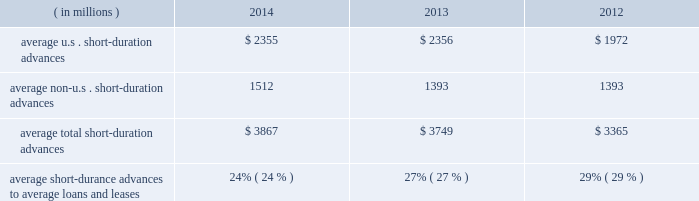Management 2019s discussion and analysis of financial condition and results of operations ( continued ) detail with respect to our investment portfolio as of december 31 , 2014 and 2013 is provided in note 3 to the consolidated financial statements included under item 8 of this form 10-k .
Loans and leases averaged $ 15.91 billion for the year ended 2014 , up from $ 13.78 billion in 2013 .
The increase was mainly related to mutual fund lending and our continued investment in senior secured bank loans .
Mutual fund lending and senior secured bank loans averaged approximately $ 9.12 billion and $ 1.40 billion , respectively , for the year ended december 31 , 2014 compared to $ 8.16 billion and $ 170 million for the year ended december 31 , 2013 , respectively .
Average loans and leases also include short- duration advances .
Table 13 : u.s .
And non-u.s .
Short-duration advances years ended december 31 .
Average u.s .
Short-duration advances $ 2355 $ 2356 $ 1972 average non-u.s .
Short-duration advances 1512 1393 1393 average total short-duration advances $ 3867 $ 3749 $ 3365 average short-durance advances to average loans and leases 24% ( 24 % ) 27% ( 27 % ) 29% ( 29 % ) the decline in proportion of the average daily short-duration advances to average loans and leases is primarily due to growth in the other segments of the loan and lease portfolio .
Short-duration advances provide liquidity to clients in support of their investment activities .
Although average short-duration advances for the year ended december 31 , 2014 increased compared to the year ended december 31 , 2013 , such average advances remained low relative to historical levels , mainly the result of clients continuing to hold higher levels of liquidity .
Average other interest-earning assets increased to $ 15.94 billion for the year ended december 31 , 2014 from $ 11.16 billion for the year ended december 31 , 2013 .
The increased levels were primarily the result of higher levels of cash collateral provided in connection with our enhanced custody business .
Aggregate average interest-bearing deposits increased to $ 130.30 billion for the year ended december 31 , 2014 from $ 109.25 billion for year ended 2013 .
The higher levels were primarily the result of increases in both u.s .
And non-u.s .
Transaction accounts and time deposits .
Future transaction account levels will be influenced by the underlying asset servicing business , as well as market conditions , including the general levels of u.s .
And non-u.s .
Interest rates .
Average other short-term borrowings increased to $ 4.18 billion for the year ended december 31 , 2014 from $ 3.79 billion for the year ended 2013 .
The increase was the result of a higher level of client demand for our commercial paper .
The decline in rates paid from 1.6% ( 1.6 % ) in 2013 to 0.1% ( 0.1 % ) in 2014 resulted from a reclassification of certain derivative contracts that hedge our interest-rate risk on certain assets and liabilities , which reduced interest revenue and interest expense .
Average long-term debt increased to $ 9.31 billion for the year ended december 31 , 2014 from $ 8.42 billion for the year ended december 31 , 2013 .
The increase primarily reflected the issuance of $ 1.5 billion of senior and subordinated debt in may 2013 , $ 1.0 billion of senior debt issued in november 2013 , and $ 1.0 billion of senior debt issued in december 2014 .
This is partially offset by the maturities of $ 500 million of senior debt in may 2014 and $ 250 million of senior debt in march 2014 .
Average other interest-bearing liabilities increased to $ 7.35 billion for the year ended december 31 , 2014 from $ 6.46 billion for the year ended december 31 , 2013 , primarily the result of higher levels of cash collateral received from clients in connection with our enhanced custody business .
Several factors could affect future levels of our net interest revenue and margin , including the mix of client liabilities ; actions of various central banks ; changes in u.s .
And non-u.s .
Interest rates ; changes in the various yield curves around the world ; revised or proposed regulatory capital or liquidity standards , or interpretations of those standards ; the amount of discount accretion generated by the former conduit securities that remain in our investment securities portfolio ; and the yields earned on securities purchased compared to the yields earned on securities sold or matured .
Based on market conditions and other factors , we continue to reinvest the majority of the proceeds from pay-downs and maturities of investment securities in highly-rated securities , such as u.s .
Treasury and agency securities , municipal securities , federal agency mortgage-backed securities and u.s .
And non-u.s .
Mortgage- and asset-backed securities .
The pace at which we continue to reinvest and the types of investment securities purchased will depend on the impact of market conditions and other factors over time .
We expect these factors and the levels of global interest rates to influence what effect our reinvestment program will have on future levels of our net interest revenue and net interest margin. .
What is the percent change in loan amount between 2013 and 2014? 
Computations: ((15.91 - 13.78) / 13.78)
Answer: 0.15457. Management 2019s discussion and analysis of financial condition and results of operations ( continued ) detail with respect to our investment portfolio as of december 31 , 2014 and 2013 is provided in note 3 to the consolidated financial statements included under item 8 of this form 10-k .
Loans and leases averaged $ 15.91 billion for the year ended 2014 , up from $ 13.78 billion in 2013 .
The increase was mainly related to mutual fund lending and our continued investment in senior secured bank loans .
Mutual fund lending and senior secured bank loans averaged approximately $ 9.12 billion and $ 1.40 billion , respectively , for the year ended december 31 , 2014 compared to $ 8.16 billion and $ 170 million for the year ended december 31 , 2013 , respectively .
Average loans and leases also include short- duration advances .
Table 13 : u.s .
And non-u.s .
Short-duration advances years ended december 31 .
Average u.s .
Short-duration advances $ 2355 $ 2356 $ 1972 average non-u.s .
Short-duration advances 1512 1393 1393 average total short-duration advances $ 3867 $ 3749 $ 3365 average short-durance advances to average loans and leases 24% ( 24 % ) 27% ( 27 % ) 29% ( 29 % ) the decline in proportion of the average daily short-duration advances to average loans and leases is primarily due to growth in the other segments of the loan and lease portfolio .
Short-duration advances provide liquidity to clients in support of their investment activities .
Although average short-duration advances for the year ended december 31 , 2014 increased compared to the year ended december 31 , 2013 , such average advances remained low relative to historical levels , mainly the result of clients continuing to hold higher levels of liquidity .
Average other interest-earning assets increased to $ 15.94 billion for the year ended december 31 , 2014 from $ 11.16 billion for the year ended december 31 , 2013 .
The increased levels were primarily the result of higher levels of cash collateral provided in connection with our enhanced custody business .
Aggregate average interest-bearing deposits increased to $ 130.30 billion for the year ended december 31 , 2014 from $ 109.25 billion for year ended 2013 .
The higher levels were primarily the result of increases in both u.s .
And non-u.s .
Transaction accounts and time deposits .
Future transaction account levels will be influenced by the underlying asset servicing business , as well as market conditions , including the general levels of u.s .
And non-u.s .
Interest rates .
Average other short-term borrowings increased to $ 4.18 billion for the year ended december 31 , 2014 from $ 3.79 billion for the year ended 2013 .
The increase was the result of a higher level of client demand for our commercial paper .
The decline in rates paid from 1.6% ( 1.6 % ) in 2013 to 0.1% ( 0.1 % ) in 2014 resulted from a reclassification of certain derivative contracts that hedge our interest-rate risk on certain assets and liabilities , which reduced interest revenue and interest expense .
Average long-term debt increased to $ 9.31 billion for the year ended december 31 , 2014 from $ 8.42 billion for the year ended december 31 , 2013 .
The increase primarily reflected the issuance of $ 1.5 billion of senior and subordinated debt in may 2013 , $ 1.0 billion of senior debt issued in november 2013 , and $ 1.0 billion of senior debt issued in december 2014 .
This is partially offset by the maturities of $ 500 million of senior debt in may 2014 and $ 250 million of senior debt in march 2014 .
Average other interest-bearing liabilities increased to $ 7.35 billion for the year ended december 31 , 2014 from $ 6.46 billion for the year ended december 31 , 2013 , primarily the result of higher levels of cash collateral received from clients in connection with our enhanced custody business .
Several factors could affect future levels of our net interest revenue and margin , including the mix of client liabilities ; actions of various central banks ; changes in u.s .
And non-u.s .
Interest rates ; changes in the various yield curves around the world ; revised or proposed regulatory capital or liquidity standards , or interpretations of those standards ; the amount of discount accretion generated by the former conduit securities that remain in our investment securities portfolio ; and the yields earned on securities purchased compared to the yields earned on securities sold or matured .
Based on market conditions and other factors , we continue to reinvest the majority of the proceeds from pay-downs and maturities of investment securities in highly-rated securities , such as u.s .
Treasury and agency securities , municipal securities , federal agency mortgage-backed securities and u.s .
And non-u.s .
Mortgage- and asset-backed securities .
The pace at which we continue to reinvest and the types of investment securities purchased will depend on the impact of market conditions and other factors over time .
We expect these factors and the levels of global interest rates to influence what effect our reinvestment program will have on future levels of our net interest revenue and net interest margin. .
What is the percent change in average u.s . short-duration advances between 2012 and 2013? 
Rationale: it looks like some of the table is in the text for some reason . something got messed up here .
Computations: ((2356 - 1972) / 1972)
Answer: 0.19473. 